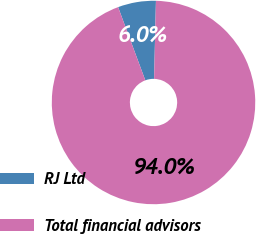<chart> <loc_0><loc_0><loc_500><loc_500><pie_chart><fcel>RJ Ltd<fcel>Total financial advisors<nl><fcel>6.04%<fcel>93.96%<nl></chart> 